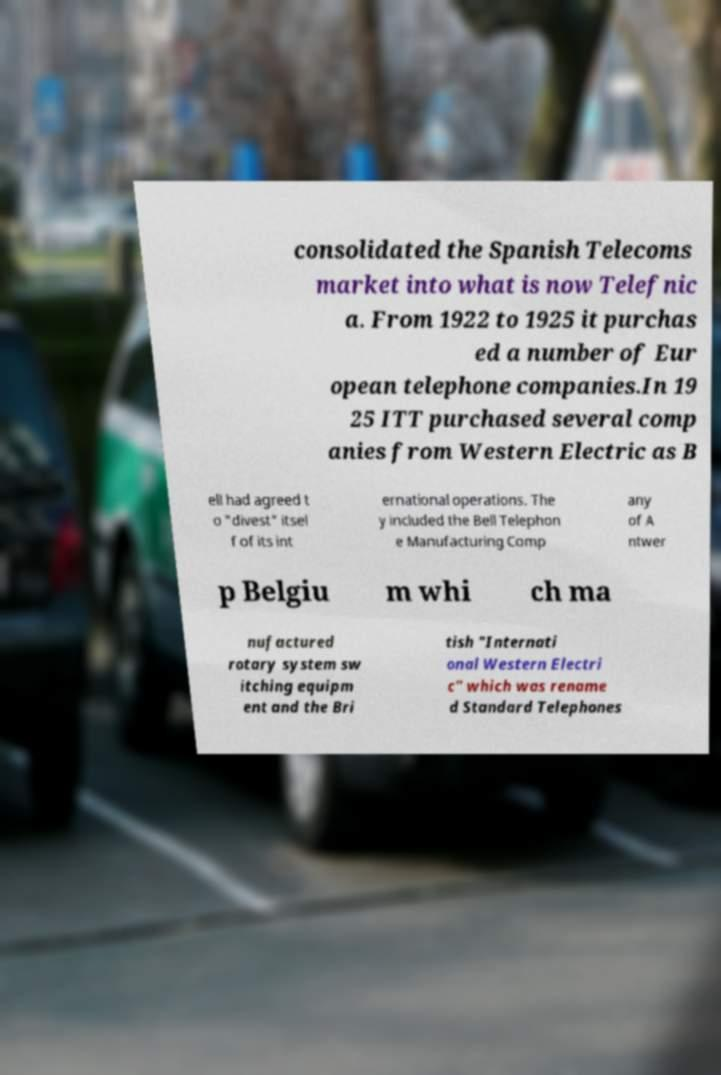For documentation purposes, I need the text within this image transcribed. Could you provide that? consolidated the Spanish Telecoms market into what is now Telefnic a. From 1922 to 1925 it purchas ed a number of Eur opean telephone companies.In 19 25 ITT purchased several comp anies from Western Electric as B ell had agreed t o "divest" itsel f of its int ernational operations. The y included the Bell Telephon e Manufacturing Comp any of A ntwer p Belgiu m whi ch ma nufactured rotary system sw itching equipm ent and the Bri tish "Internati onal Western Electri c" which was rename d Standard Telephones 